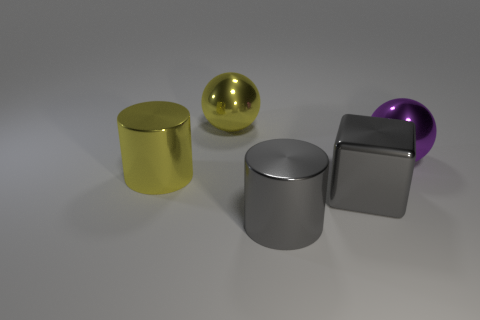The purple thing is what shape?
Keep it short and to the point. Sphere. Is the number of big yellow things that are on the left side of the yellow metal sphere greater than the number of big blue rubber objects?
Your answer should be compact. Yes. What is the shape of the metallic thing that is in front of the gray block?
Offer a very short reply. Cylinder. What number of other things are there of the same shape as the purple metallic object?
Your response must be concise. 1. Are there an equal number of yellow cylinders that are in front of the large yellow cylinder and big spheres that are in front of the gray cube?
Provide a short and direct response. Yes. There is a gray metal object that is to the right of the gray shiny cylinder; what is its size?
Your answer should be very brief. Large. Is there a large purple sphere that has the same material as the yellow cylinder?
Provide a succinct answer. Yes. There is a large metallic cylinder that is to the right of the large yellow ball; is its color the same as the large shiny cube?
Your answer should be very brief. Yes. Is the number of large yellow shiny things that are right of the purple thing the same as the number of big metallic spheres?
Your response must be concise. No. Are there any rubber objects that have the same color as the big cube?
Offer a terse response. No. 